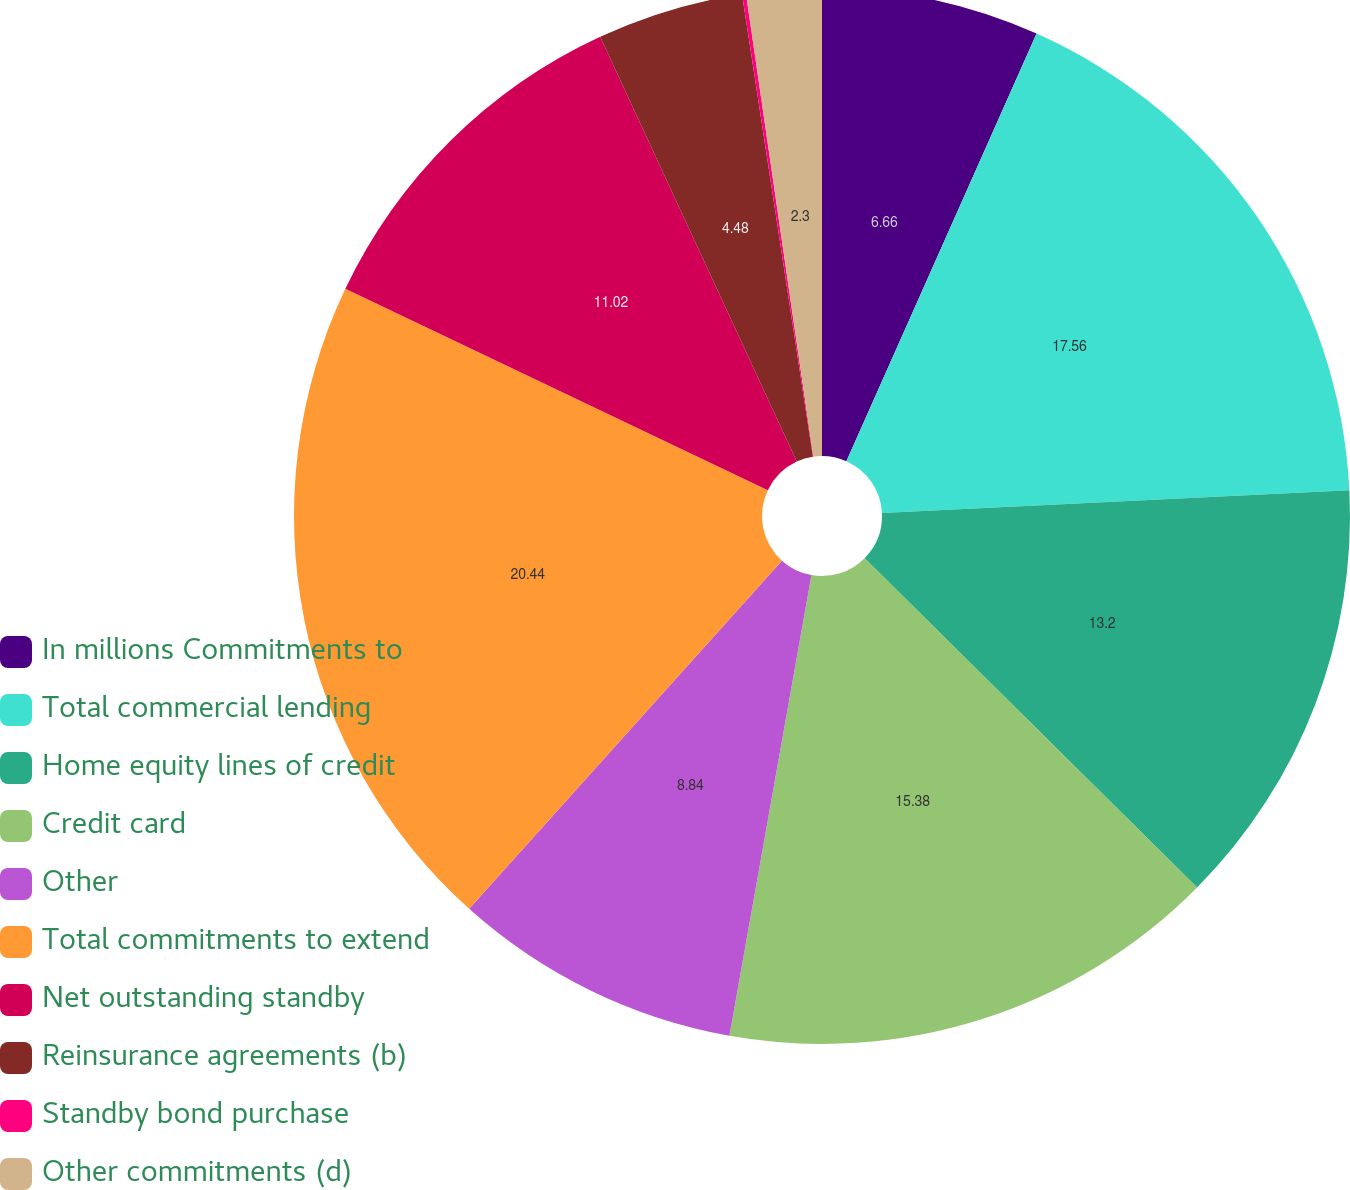Convert chart. <chart><loc_0><loc_0><loc_500><loc_500><pie_chart><fcel>In millions Commitments to<fcel>Total commercial lending<fcel>Home equity lines of credit<fcel>Credit card<fcel>Other<fcel>Total commitments to extend<fcel>Net outstanding standby<fcel>Reinsurance agreements (b)<fcel>Standby bond purchase<fcel>Other commitments (d)<nl><fcel>6.66%<fcel>17.56%<fcel>13.2%<fcel>15.38%<fcel>8.84%<fcel>20.43%<fcel>11.02%<fcel>4.48%<fcel>0.12%<fcel>2.3%<nl></chart> 